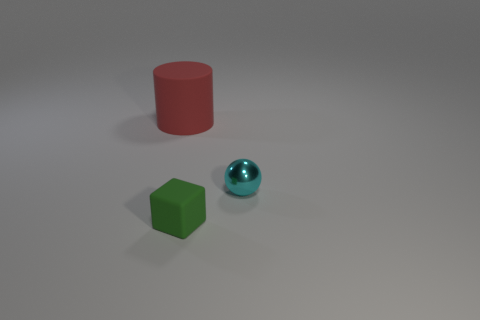Add 2 green things. How many objects exist? 5 Subtract all spheres. How many objects are left? 2 Subtract all yellow shiny objects. Subtract all large red things. How many objects are left? 2 Add 1 tiny green matte blocks. How many tiny green matte blocks are left? 2 Add 3 yellow metal objects. How many yellow metal objects exist? 3 Subtract 0 brown spheres. How many objects are left? 3 